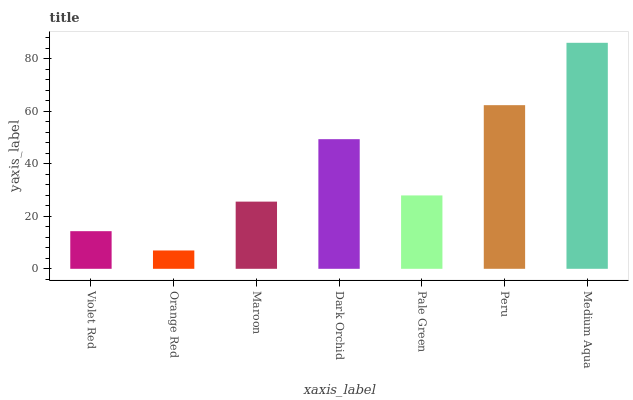Is Orange Red the minimum?
Answer yes or no. Yes. Is Medium Aqua the maximum?
Answer yes or no. Yes. Is Maroon the minimum?
Answer yes or no. No. Is Maroon the maximum?
Answer yes or no. No. Is Maroon greater than Orange Red?
Answer yes or no. Yes. Is Orange Red less than Maroon?
Answer yes or no. Yes. Is Orange Red greater than Maroon?
Answer yes or no. No. Is Maroon less than Orange Red?
Answer yes or no. No. Is Pale Green the high median?
Answer yes or no. Yes. Is Pale Green the low median?
Answer yes or no. Yes. Is Maroon the high median?
Answer yes or no. No. Is Orange Red the low median?
Answer yes or no. No. 